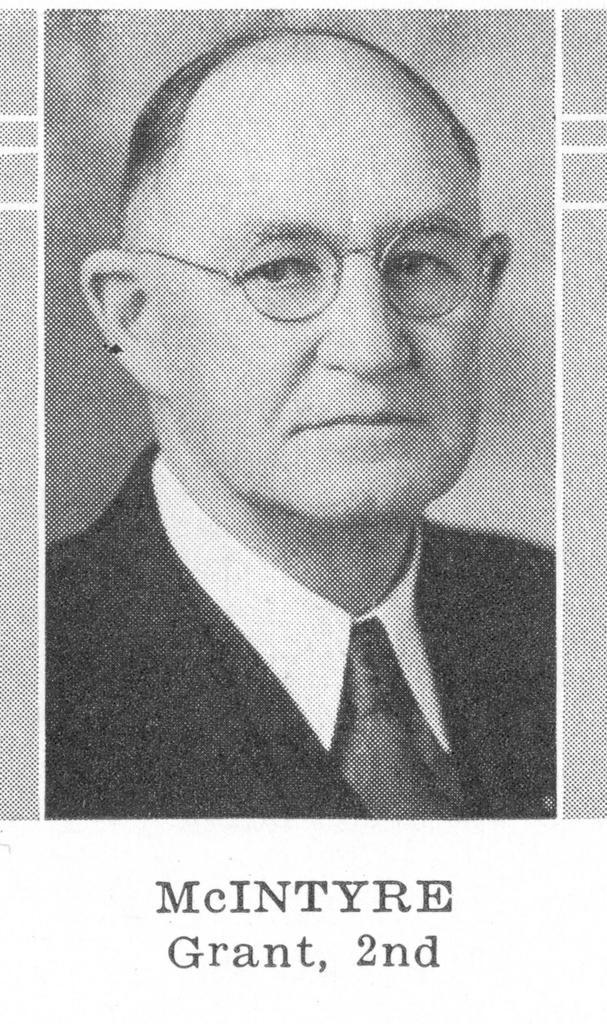How would you summarize this image in a sentence or two? This is a black and white image. In this we can see a photo of a person with specs. At the bottom of the image something is written. 